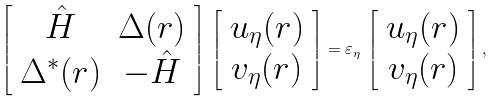Convert formula to latex. <formula><loc_0><loc_0><loc_500><loc_500>\left [ \begin{array} { c c } \hat { H } & \Delta ( { r } ) \\ \Delta ^ { * } ( { r } ) & - \hat { H } \end{array} \right ] \, \left [ \begin{array} { c } u _ { \eta } ( { r } ) \\ v _ { \eta } ( { r } ) \end{array} \right ] = \varepsilon _ { \eta } \, \left [ \begin{array} { c } u _ { \eta } ( { r } ) \\ v _ { \eta } ( { r } ) \end{array} \right ] ,</formula> 